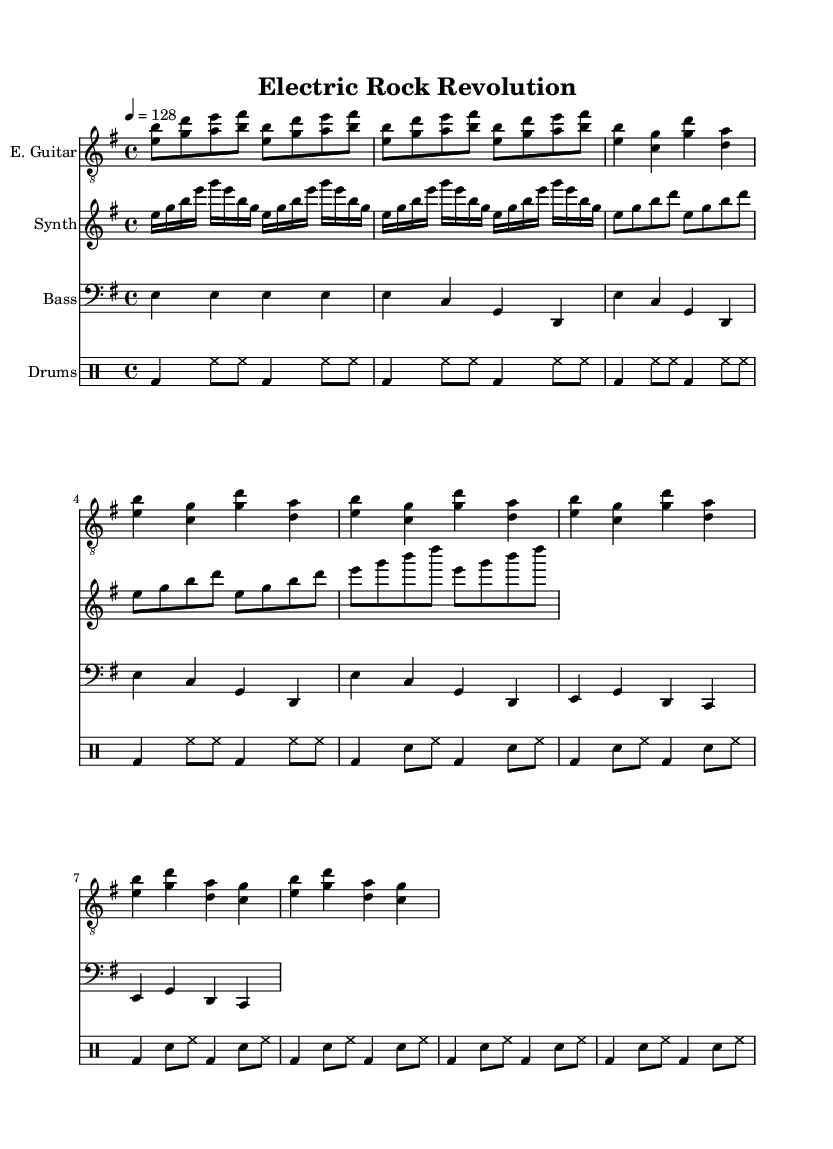What is the key signature of this music? The key signature is E minor, which has one sharp (F sharp) indicated on the staff. You can identify the key signature by looking at the sharps or flats at the beginning of the music.
Answer: E minor What is the time signature of the piece? The time signature shown is 4/4, which means there are four beats in each measure and the quarter note gets one beat. You can find the time signature at the beginning of the music, typically represented as a fraction.
Answer: 4/4 What is the tempo marking for this piece? The tempo marking is 128, indicated by "4 = 128," meaning there are 128 beats per minute. The tempo marking is usually placed above the staff, specifying the speed of the music.
Answer: 128 How many measures are in the verse section? The verse section is repeated four times and has two measures each time, giving a total of eight measures. To find this, look at the repeat indicators and count the measures within that section.
Answer: 8 What is the relationship between the electric guitar and synthesizer parts in the chorus? The electric guitar and synthesizer play similar rhythmic patterns using the same notes in the chorus. This creates a harmony where both instruments complement each other, with the synthesizer playing eighth notes while the guitar plays quarter notes. This relationship can be seen by comparing the notes played during the chorus sections of both staves.
Answer: Harmonious What instrument is playing the intro of the piece? The instrument playing the intro is the electric guitar, as indicated at the beginning of that staff. You can tell which instrument is playing by looking at the instrument names labeled at the start of each staff.
Answer: Electric Guitar What distinguishes the drums part in the verse section from the chorus? In the drums part, the verse features a snare hit after every bass drum strike, while the chorus maintains a similar pattern but with less emphasis on the snare. This difference can be identified by examining the rhythm patterns in each section.
Answer: Snare emphasis 